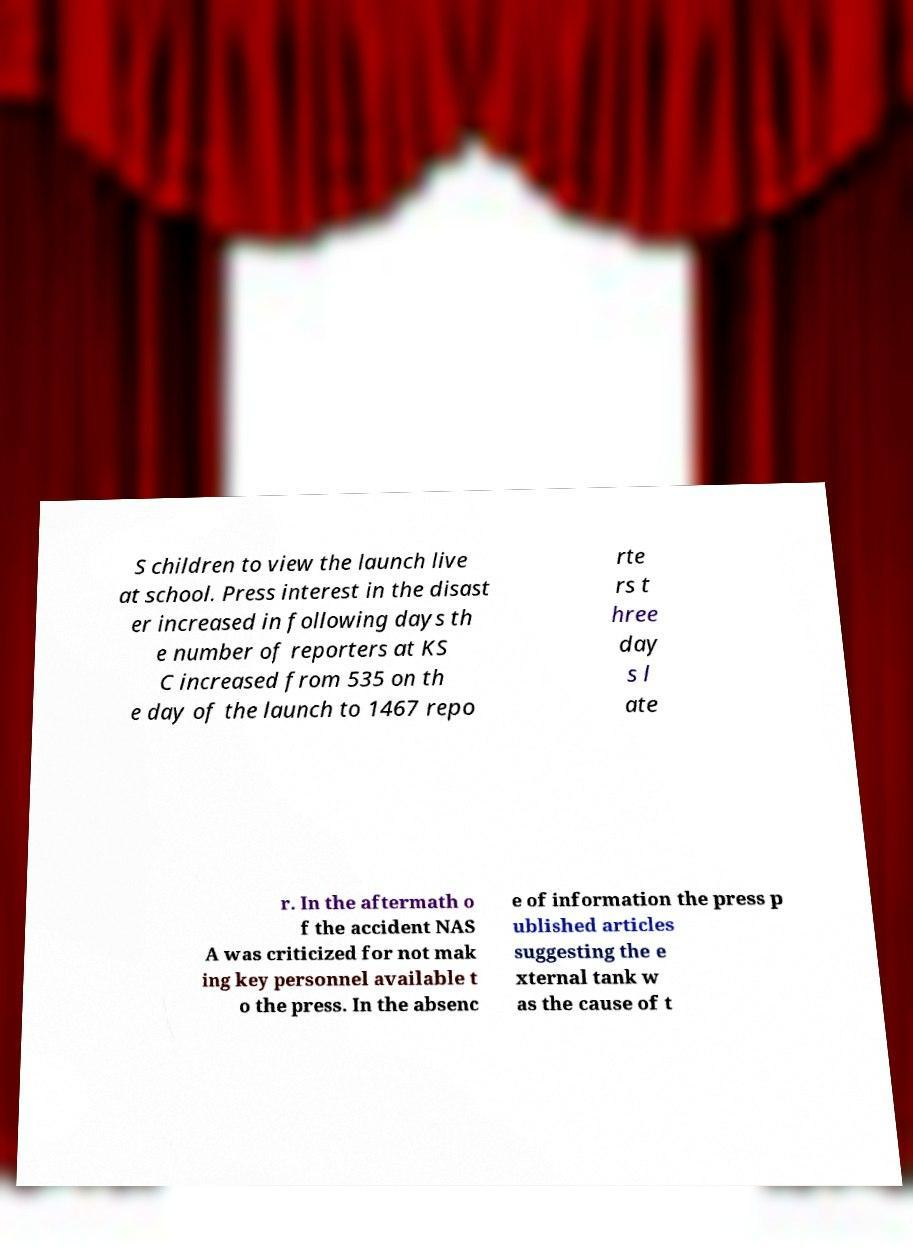There's text embedded in this image that I need extracted. Can you transcribe it verbatim? S children to view the launch live at school. Press interest in the disast er increased in following days th e number of reporters at KS C increased from 535 on th e day of the launch to 1467 repo rte rs t hree day s l ate r. In the aftermath o f the accident NAS A was criticized for not mak ing key personnel available t o the press. In the absenc e of information the press p ublished articles suggesting the e xternal tank w as the cause of t 